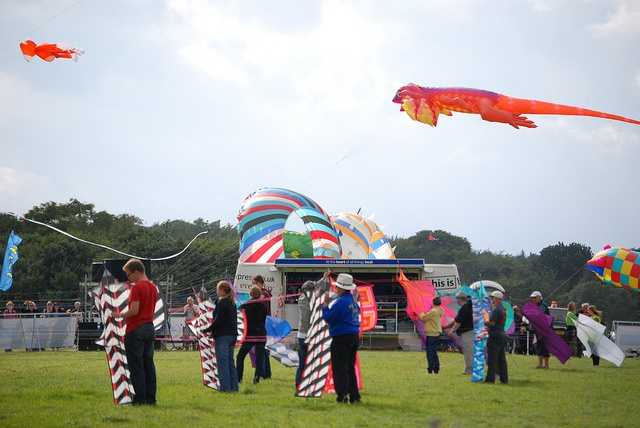Describe the objects in this image and their specific colors. I can see kite in lightgray, black, gray, and navy tones, people in lightgray, black, gray, darkgray, and maroon tones, kite in lightgray, white, lightblue, salmon, and gray tones, kite in lightgray, salmon, red, and orange tones, and people in lightgray, black, maroon, and brown tones in this image. 